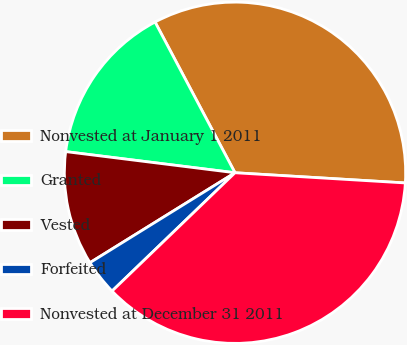<chart> <loc_0><loc_0><loc_500><loc_500><pie_chart><fcel>Nonvested at January 1 2011<fcel>Granted<fcel>Vested<fcel>Forfeited<fcel>Nonvested at December 31 2011<nl><fcel>33.71%<fcel>15.26%<fcel>10.81%<fcel>3.36%<fcel>36.85%<nl></chart> 